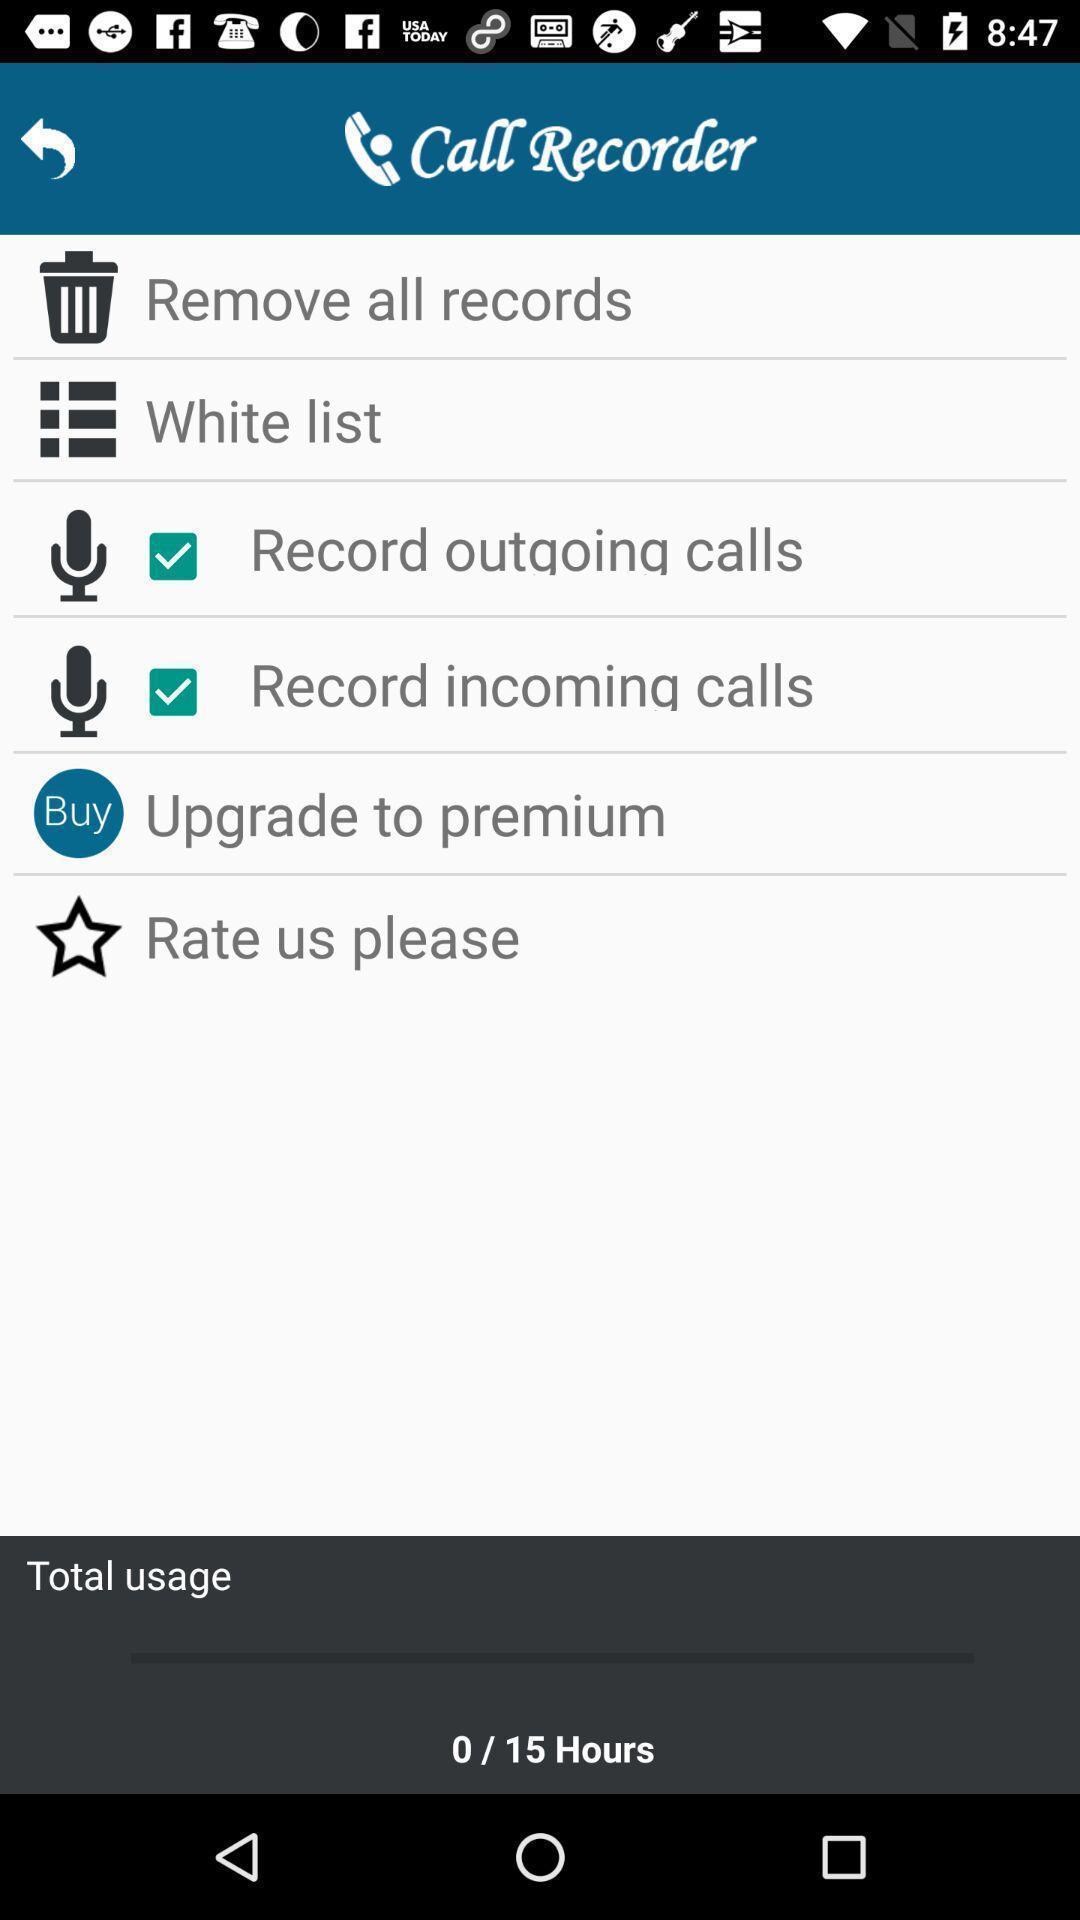Summarize the main components in this picture. Screen showing options for call recorder. 